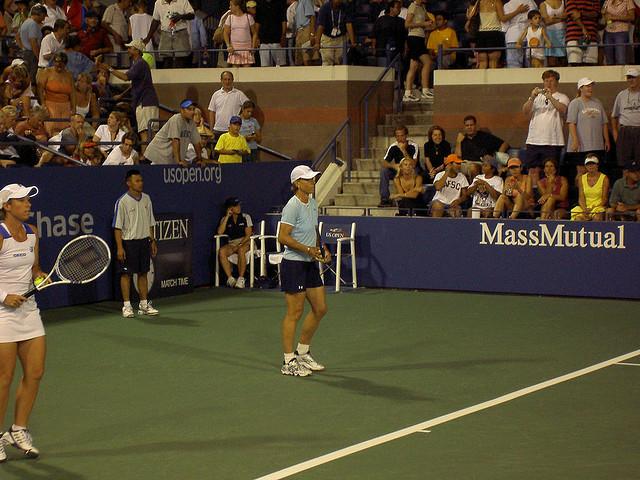Which tennis player is wearing a dress?
Short answer required. Left 1. What color hats do the tennis players have?
Answer briefly. White. What are they holding?
Short answer required. Tennis rackets. 